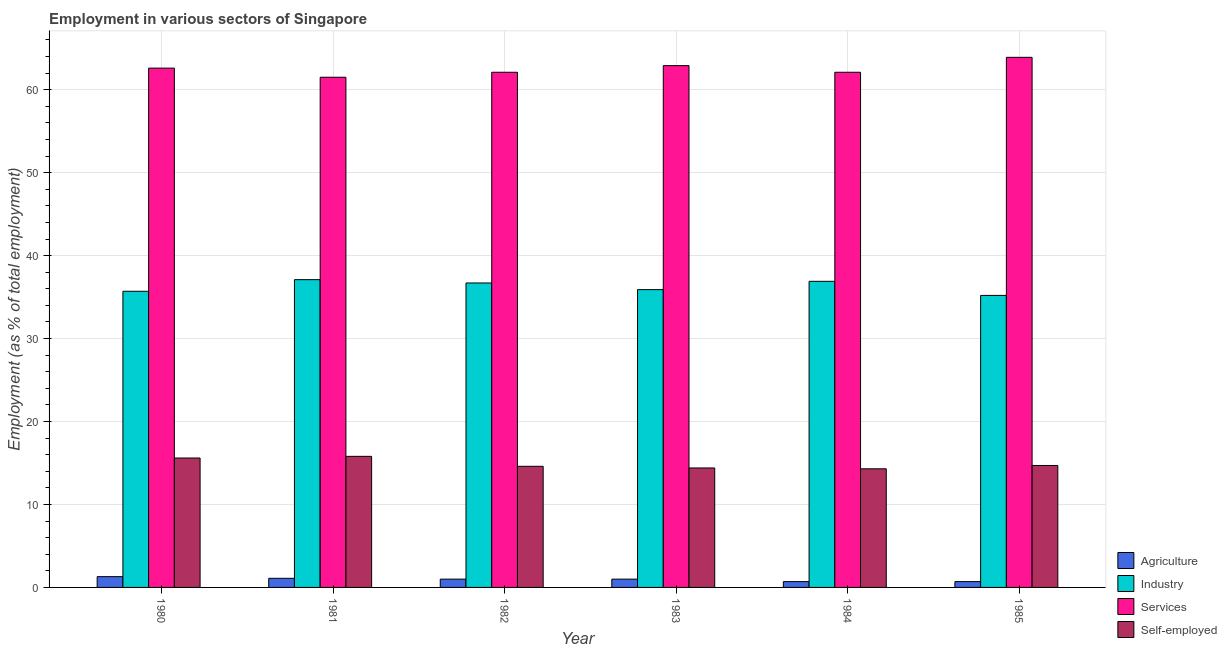How many different coloured bars are there?
Your response must be concise. 4. How many groups of bars are there?
Make the answer very short. 6. Are the number of bars on each tick of the X-axis equal?
Your answer should be very brief. Yes. How many bars are there on the 2nd tick from the left?
Ensure brevity in your answer.  4. In how many cases, is the number of bars for a given year not equal to the number of legend labels?
Make the answer very short. 0. What is the percentage of workers in services in 1981?
Offer a terse response. 61.5. Across all years, what is the maximum percentage of workers in services?
Provide a short and direct response. 63.9. Across all years, what is the minimum percentage of workers in agriculture?
Your response must be concise. 0.7. In which year was the percentage of workers in services minimum?
Give a very brief answer. 1981. What is the total percentage of workers in agriculture in the graph?
Offer a terse response. 5.8. What is the difference between the percentage of workers in industry in 1981 and that in 1985?
Provide a succinct answer. 1.9. What is the difference between the percentage of self employed workers in 1983 and the percentage of workers in industry in 1980?
Provide a short and direct response. -1.2. What is the average percentage of workers in industry per year?
Provide a short and direct response. 36.25. In how many years, is the percentage of workers in agriculture greater than 52 %?
Your answer should be very brief. 0. What is the ratio of the percentage of workers in services in 1981 to that in 1985?
Your response must be concise. 0.96. Is the percentage of workers in services in 1981 less than that in 1982?
Give a very brief answer. Yes. Is the difference between the percentage of self employed workers in 1981 and 1982 greater than the difference between the percentage of workers in industry in 1981 and 1982?
Provide a succinct answer. No. What is the difference between the highest and the second highest percentage of workers in services?
Your response must be concise. 1. What is the difference between the highest and the lowest percentage of self employed workers?
Your answer should be very brief. 1.5. In how many years, is the percentage of self employed workers greater than the average percentage of self employed workers taken over all years?
Your response must be concise. 2. Is it the case that in every year, the sum of the percentage of workers in industry and percentage of workers in agriculture is greater than the sum of percentage of workers in services and percentage of self employed workers?
Offer a very short reply. Yes. What does the 2nd bar from the left in 1984 represents?
Your response must be concise. Industry. What does the 4th bar from the right in 1983 represents?
Offer a very short reply. Agriculture. How many bars are there?
Ensure brevity in your answer.  24. Are all the bars in the graph horizontal?
Keep it short and to the point. No. What is the difference between two consecutive major ticks on the Y-axis?
Your answer should be compact. 10. Does the graph contain grids?
Provide a succinct answer. Yes. How are the legend labels stacked?
Offer a terse response. Vertical. What is the title of the graph?
Provide a short and direct response. Employment in various sectors of Singapore. What is the label or title of the X-axis?
Give a very brief answer. Year. What is the label or title of the Y-axis?
Your answer should be compact. Employment (as % of total employment). What is the Employment (as % of total employment) of Agriculture in 1980?
Offer a very short reply. 1.3. What is the Employment (as % of total employment) of Industry in 1980?
Your response must be concise. 35.7. What is the Employment (as % of total employment) in Services in 1980?
Make the answer very short. 62.6. What is the Employment (as % of total employment) of Self-employed in 1980?
Your answer should be very brief. 15.6. What is the Employment (as % of total employment) in Agriculture in 1981?
Make the answer very short. 1.1. What is the Employment (as % of total employment) in Industry in 1981?
Provide a short and direct response. 37.1. What is the Employment (as % of total employment) in Services in 1981?
Offer a terse response. 61.5. What is the Employment (as % of total employment) in Self-employed in 1981?
Your answer should be compact. 15.8. What is the Employment (as % of total employment) of Industry in 1982?
Provide a succinct answer. 36.7. What is the Employment (as % of total employment) of Services in 1982?
Your answer should be compact. 62.1. What is the Employment (as % of total employment) in Self-employed in 1982?
Your answer should be very brief. 14.6. What is the Employment (as % of total employment) in Industry in 1983?
Ensure brevity in your answer.  35.9. What is the Employment (as % of total employment) in Services in 1983?
Provide a short and direct response. 62.9. What is the Employment (as % of total employment) of Self-employed in 1983?
Offer a very short reply. 14.4. What is the Employment (as % of total employment) in Agriculture in 1984?
Keep it short and to the point. 0.7. What is the Employment (as % of total employment) in Industry in 1984?
Make the answer very short. 36.9. What is the Employment (as % of total employment) in Services in 1984?
Your answer should be very brief. 62.1. What is the Employment (as % of total employment) of Self-employed in 1984?
Make the answer very short. 14.3. What is the Employment (as % of total employment) of Agriculture in 1985?
Offer a very short reply. 0.7. What is the Employment (as % of total employment) of Industry in 1985?
Ensure brevity in your answer.  35.2. What is the Employment (as % of total employment) of Services in 1985?
Your answer should be compact. 63.9. What is the Employment (as % of total employment) of Self-employed in 1985?
Keep it short and to the point. 14.7. Across all years, what is the maximum Employment (as % of total employment) in Agriculture?
Give a very brief answer. 1.3. Across all years, what is the maximum Employment (as % of total employment) in Industry?
Offer a very short reply. 37.1. Across all years, what is the maximum Employment (as % of total employment) in Services?
Provide a succinct answer. 63.9. Across all years, what is the maximum Employment (as % of total employment) of Self-employed?
Offer a very short reply. 15.8. Across all years, what is the minimum Employment (as % of total employment) in Agriculture?
Your response must be concise. 0.7. Across all years, what is the minimum Employment (as % of total employment) in Industry?
Your answer should be compact. 35.2. Across all years, what is the minimum Employment (as % of total employment) of Services?
Give a very brief answer. 61.5. Across all years, what is the minimum Employment (as % of total employment) in Self-employed?
Make the answer very short. 14.3. What is the total Employment (as % of total employment) of Agriculture in the graph?
Give a very brief answer. 5.8. What is the total Employment (as % of total employment) of Industry in the graph?
Ensure brevity in your answer.  217.5. What is the total Employment (as % of total employment) in Services in the graph?
Offer a terse response. 375.1. What is the total Employment (as % of total employment) of Self-employed in the graph?
Provide a short and direct response. 89.4. What is the difference between the Employment (as % of total employment) of Industry in 1980 and that in 1981?
Offer a very short reply. -1.4. What is the difference between the Employment (as % of total employment) in Industry in 1980 and that in 1982?
Offer a very short reply. -1. What is the difference between the Employment (as % of total employment) of Services in 1980 and that in 1982?
Give a very brief answer. 0.5. What is the difference between the Employment (as % of total employment) of Agriculture in 1980 and that in 1983?
Ensure brevity in your answer.  0.3. What is the difference between the Employment (as % of total employment) of Industry in 1980 and that in 1983?
Your answer should be very brief. -0.2. What is the difference between the Employment (as % of total employment) in Self-employed in 1980 and that in 1983?
Give a very brief answer. 1.2. What is the difference between the Employment (as % of total employment) of Industry in 1980 and that in 1984?
Provide a short and direct response. -1.2. What is the difference between the Employment (as % of total employment) in Agriculture in 1980 and that in 1985?
Offer a very short reply. 0.6. What is the difference between the Employment (as % of total employment) of Industry in 1980 and that in 1985?
Your answer should be compact. 0.5. What is the difference between the Employment (as % of total employment) of Industry in 1981 and that in 1983?
Your answer should be compact. 1.2. What is the difference between the Employment (as % of total employment) of Self-employed in 1981 and that in 1983?
Provide a short and direct response. 1.4. What is the difference between the Employment (as % of total employment) in Industry in 1981 and that in 1984?
Ensure brevity in your answer.  0.2. What is the difference between the Employment (as % of total employment) of Services in 1981 and that in 1984?
Ensure brevity in your answer.  -0.6. What is the difference between the Employment (as % of total employment) of Self-employed in 1981 and that in 1984?
Provide a short and direct response. 1.5. What is the difference between the Employment (as % of total employment) in Industry in 1982 and that in 1983?
Offer a terse response. 0.8. What is the difference between the Employment (as % of total employment) of Services in 1982 and that in 1983?
Make the answer very short. -0.8. What is the difference between the Employment (as % of total employment) in Self-employed in 1982 and that in 1983?
Give a very brief answer. 0.2. What is the difference between the Employment (as % of total employment) in Agriculture in 1982 and that in 1984?
Ensure brevity in your answer.  0.3. What is the difference between the Employment (as % of total employment) of Industry in 1982 and that in 1984?
Make the answer very short. -0.2. What is the difference between the Employment (as % of total employment) in Agriculture in 1982 and that in 1985?
Make the answer very short. 0.3. What is the difference between the Employment (as % of total employment) of Self-employed in 1982 and that in 1985?
Offer a very short reply. -0.1. What is the difference between the Employment (as % of total employment) in Services in 1983 and that in 1984?
Offer a very short reply. 0.8. What is the difference between the Employment (as % of total employment) of Self-employed in 1983 and that in 1984?
Keep it short and to the point. 0.1. What is the difference between the Employment (as % of total employment) in Industry in 1983 and that in 1985?
Keep it short and to the point. 0.7. What is the difference between the Employment (as % of total employment) in Services in 1983 and that in 1985?
Ensure brevity in your answer.  -1. What is the difference between the Employment (as % of total employment) in Services in 1984 and that in 1985?
Provide a succinct answer. -1.8. What is the difference between the Employment (as % of total employment) in Agriculture in 1980 and the Employment (as % of total employment) in Industry in 1981?
Make the answer very short. -35.8. What is the difference between the Employment (as % of total employment) of Agriculture in 1980 and the Employment (as % of total employment) of Services in 1981?
Offer a very short reply. -60.2. What is the difference between the Employment (as % of total employment) of Agriculture in 1980 and the Employment (as % of total employment) of Self-employed in 1981?
Offer a very short reply. -14.5. What is the difference between the Employment (as % of total employment) in Industry in 1980 and the Employment (as % of total employment) in Services in 1981?
Make the answer very short. -25.8. What is the difference between the Employment (as % of total employment) of Industry in 1980 and the Employment (as % of total employment) of Self-employed in 1981?
Make the answer very short. 19.9. What is the difference between the Employment (as % of total employment) in Services in 1980 and the Employment (as % of total employment) in Self-employed in 1981?
Offer a very short reply. 46.8. What is the difference between the Employment (as % of total employment) in Agriculture in 1980 and the Employment (as % of total employment) in Industry in 1982?
Ensure brevity in your answer.  -35.4. What is the difference between the Employment (as % of total employment) of Agriculture in 1980 and the Employment (as % of total employment) of Services in 1982?
Your answer should be very brief. -60.8. What is the difference between the Employment (as % of total employment) of Industry in 1980 and the Employment (as % of total employment) of Services in 1982?
Your answer should be compact. -26.4. What is the difference between the Employment (as % of total employment) of Industry in 1980 and the Employment (as % of total employment) of Self-employed in 1982?
Provide a short and direct response. 21.1. What is the difference between the Employment (as % of total employment) of Agriculture in 1980 and the Employment (as % of total employment) of Industry in 1983?
Give a very brief answer. -34.6. What is the difference between the Employment (as % of total employment) in Agriculture in 1980 and the Employment (as % of total employment) in Services in 1983?
Your answer should be very brief. -61.6. What is the difference between the Employment (as % of total employment) of Industry in 1980 and the Employment (as % of total employment) of Services in 1983?
Offer a very short reply. -27.2. What is the difference between the Employment (as % of total employment) of Industry in 1980 and the Employment (as % of total employment) of Self-employed in 1983?
Your response must be concise. 21.3. What is the difference between the Employment (as % of total employment) of Services in 1980 and the Employment (as % of total employment) of Self-employed in 1983?
Your answer should be very brief. 48.2. What is the difference between the Employment (as % of total employment) of Agriculture in 1980 and the Employment (as % of total employment) of Industry in 1984?
Ensure brevity in your answer.  -35.6. What is the difference between the Employment (as % of total employment) of Agriculture in 1980 and the Employment (as % of total employment) of Services in 1984?
Provide a short and direct response. -60.8. What is the difference between the Employment (as % of total employment) of Agriculture in 1980 and the Employment (as % of total employment) of Self-employed in 1984?
Provide a short and direct response. -13. What is the difference between the Employment (as % of total employment) of Industry in 1980 and the Employment (as % of total employment) of Services in 1984?
Provide a succinct answer. -26.4. What is the difference between the Employment (as % of total employment) of Industry in 1980 and the Employment (as % of total employment) of Self-employed in 1984?
Give a very brief answer. 21.4. What is the difference between the Employment (as % of total employment) of Services in 1980 and the Employment (as % of total employment) of Self-employed in 1984?
Your response must be concise. 48.3. What is the difference between the Employment (as % of total employment) in Agriculture in 1980 and the Employment (as % of total employment) in Industry in 1985?
Your answer should be very brief. -33.9. What is the difference between the Employment (as % of total employment) in Agriculture in 1980 and the Employment (as % of total employment) in Services in 1985?
Your answer should be compact. -62.6. What is the difference between the Employment (as % of total employment) in Industry in 1980 and the Employment (as % of total employment) in Services in 1985?
Provide a short and direct response. -28.2. What is the difference between the Employment (as % of total employment) in Industry in 1980 and the Employment (as % of total employment) in Self-employed in 1985?
Make the answer very short. 21. What is the difference between the Employment (as % of total employment) of Services in 1980 and the Employment (as % of total employment) of Self-employed in 1985?
Offer a terse response. 47.9. What is the difference between the Employment (as % of total employment) in Agriculture in 1981 and the Employment (as % of total employment) in Industry in 1982?
Offer a very short reply. -35.6. What is the difference between the Employment (as % of total employment) of Agriculture in 1981 and the Employment (as % of total employment) of Services in 1982?
Keep it short and to the point. -61. What is the difference between the Employment (as % of total employment) in Services in 1981 and the Employment (as % of total employment) in Self-employed in 1982?
Keep it short and to the point. 46.9. What is the difference between the Employment (as % of total employment) in Agriculture in 1981 and the Employment (as % of total employment) in Industry in 1983?
Give a very brief answer. -34.8. What is the difference between the Employment (as % of total employment) in Agriculture in 1981 and the Employment (as % of total employment) in Services in 1983?
Make the answer very short. -61.8. What is the difference between the Employment (as % of total employment) in Industry in 1981 and the Employment (as % of total employment) in Services in 1983?
Your answer should be compact. -25.8. What is the difference between the Employment (as % of total employment) in Industry in 1981 and the Employment (as % of total employment) in Self-employed in 1983?
Keep it short and to the point. 22.7. What is the difference between the Employment (as % of total employment) in Services in 1981 and the Employment (as % of total employment) in Self-employed in 1983?
Ensure brevity in your answer.  47.1. What is the difference between the Employment (as % of total employment) in Agriculture in 1981 and the Employment (as % of total employment) in Industry in 1984?
Make the answer very short. -35.8. What is the difference between the Employment (as % of total employment) in Agriculture in 1981 and the Employment (as % of total employment) in Services in 1984?
Offer a very short reply. -61. What is the difference between the Employment (as % of total employment) of Industry in 1981 and the Employment (as % of total employment) of Self-employed in 1984?
Your response must be concise. 22.8. What is the difference between the Employment (as % of total employment) of Services in 1981 and the Employment (as % of total employment) of Self-employed in 1984?
Make the answer very short. 47.2. What is the difference between the Employment (as % of total employment) in Agriculture in 1981 and the Employment (as % of total employment) in Industry in 1985?
Keep it short and to the point. -34.1. What is the difference between the Employment (as % of total employment) in Agriculture in 1981 and the Employment (as % of total employment) in Services in 1985?
Your answer should be compact. -62.8. What is the difference between the Employment (as % of total employment) of Industry in 1981 and the Employment (as % of total employment) of Services in 1985?
Make the answer very short. -26.8. What is the difference between the Employment (as % of total employment) of Industry in 1981 and the Employment (as % of total employment) of Self-employed in 1985?
Your answer should be very brief. 22.4. What is the difference between the Employment (as % of total employment) of Services in 1981 and the Employment (as % of total employment) of Self-employed in 1985?
Ensure brevity in your answer.  46.8. What is the difference between the Employment (as % of total employment) of Agriculture in 1982 and the Employment (as % of total employment) of Industry in 1983?
Make the answer very short. -34.9. What is the difference between the Employment (as % of total employment) in Agriculture in 1982 and the Employment (as % of total employment) in Services in 1983?
Your answer should be compact. -61.9. What is the difference between the Employment (as % of total employment) of Industry in 1982 and the Employment (as % of total employment) of Services in 1983?
Offer a terse response. -26.2. What is the difference between the Employment (as % of total employment) of Industry in 1982 and the Employment (as % of total employment) of Self-employed in 1983?
Ensure brevity in your answer.  22.3. What is the difference between the Employment (as % of total employment) in Services in 1982 and the Employment (as % of total employment) in Self-employed in 1983?
Make the answer very short. 47.7. What is the difference between the Employment (as % of total employment) of Agriculture in 1982 and the Employment (as % of total employment) of Industry in 1984?
Your answer should be compact. -35.9. What is the difference between the Employment (as % of total employment) in Agriculture in 1982 and the Employment (as % of total employment) in Services in 1984?
Provide a short and direct response. -61.1. What is the difference between the Employment (as % of total employment) in Industry in 1982 and the Employment (as % of total employment) in Services in 1984?
Your answer should be compact. -25.4. What is the difference between the Employment (as % of total employment) in Industry in 1982 and the Employment (as % of total employment) in Self-employed in 1984?
Keep it short and to the point. 22.4. What is the difference between the Employment (as % of total employment) of Services in 1982 and the Employment (as % of total employment) of Self-employed in 1984?
Ensure brevity in your answer.  47.8. What is the difference between the Employment (as % of total employment) in Agriculture in 1982 and the Employment (as % of total employment) in Industry in 1985?
Make the answer very short. -34.2. What is the difference between the Employment (as % of total employment) of Agriculture in 1982 and the Employment (as % of total employment) of Services in 1985?
Offer a very short reply. -62.9. What is the difference between the Employment (as % of total employment) of Agriculture in 1982 and the Employment (as % of total employment) of Self-employed in 1985?
Give a very brief answer. -13.7. What is the difference between the Employment (as % of total employment) of Industry in 1982 and the Employment (as % of total employment) of Services in 1985?
Ensure brevity in your answer.  -27.2. What is the difference between the Employment (as % of total employment) in Services in 1982 and the Employment (as % of total employment) in Self-employed in 1985?
Provide a succinct answer. 47.4. What is the difference between the Employment (as % of total employment) of Agriculture in 1983 and the Employment (as % of total employment) of Industry in 1984?
Offer a terse response. -35.9. What is the difference between the Employment (as % of total employment) of Agriculture in 1983 and the Employment (as % of total employment) of Services in 1984?
Ensure brevity in your answer.  -61.1. What is the difference between the Employment (as % of total employment) in Agriculture in 1983 and the Employment (as % of total employment) in Self-employed in 1984?
Ensure brevity in your answer.  -13.3. What is the difference between the Employment (as % of total employment) in Industry in 1983 and the Employment (as % of total employment) in Services in 1984?
Make the answer very short. -26.2. What is the difference between the Employment (as % of total employment) of Industry in 1983 and the Employment (as % of total employment) of Self-employed in 1984?
Your answer should be compact. 21.6. What is the difference between the Employment (as % of total employment) of Services in 1983 and the Employment (as % of total employment) of Self-employed in 1984?
Provide a short and direct response. 48.6. What is the difference between the Employment (as % of total employment) in Agriculture in 1983 and the Employment (as % of total employment) in Industry in 1985?
Keep it short and to the point. -34.2. What is the difference between the Employment (as % of total employment) in Agriculture in 1983 and the Employment (as % of total employment) in Services in 1985?
Your response must be concise. -62.9. What is the difference between the Employment (as % of total employment) in Agriculture in 1983 and the Employment (as % of total employment) in Self-employed in 1985?
Give a very brief answer. -13.7. What is the difference between the Employment (as % of total employment) in Industry in 1983 and the Employment (as % of total employment) in Services in 1985?
Your answer should be very brief. -28. What is the difference between the Employment (as % of total employment) in Industry in 1983 and the Employment (as % of total employment) in Self-employed in 1985?
Keep it short and to the point. 21.2. What is the difference between the Employment (as % of total employment) of Services in 1983 and the Employment (as % of total employment) of Self-employed in 1985?
Your answer should be very brief. 48.2. What is the difference between the Employment (as % of total employment) of Agriculture in 1984 and the Employment (as % of total employment) of Industry in 1985?
Give a very brief answer. -34.5. What is the difference between the Employment (as % of total employment) in Agriculture in 1984 and the Employment (as % of total employment) in Services in 1985?
Offer a terse response. -63.2. What is the difference between the Employment (as % of total employment) of Industry in 1984 and the Employment (as % of total employment) of Services in 1985?
Your response must be concise. -27. What is the difference between the Employment (as % of total employment) of Services in 1984 and the Employment (as % of total employment) of Self-employed in 1985?
Your answer should be very brief. 47.4. What is the average Employment (as % of total employment) of Agriculture per year?
Give a very brief answer. 0.97. What is the average Employment (as % of total employment) of Industry per year?
Your answer should be compact. 36.25. What is the average Employment (as % of total employment) of Services per year?
Your answer should be compact. 62.52. What is the average Employment (as % of total employment) in Self-employed per year?
Offer a terse response. 14.9. In the year 1980, what is the difference between the Employment (as % of total employment) of Agriculture and Employment (as % of total employment) of Industry?
Provide a short and direct response. -34.4. In the year 1980, what is the difference between the Employment (as % of total employment) in Agriculture and Employment (as % of total employment) in Services?
Your answer should be compact. -61.3. In the year 1980, what is the difference between the Employment (as % of total employment) in Agriculture and Employment (as % of total employment) in Self-employed?
Your answer should be compact. -14.3. In the year 1980, what is the difference between the Employment (as % of total employment) of Industry and Employment (as % of total employment) of Services?
Ensure brevity in your answer.  -26.9. In the year 1980, what is the difference between the Employment (as % of total employment) in Industry and Employment (as % of total employment) in Self-employed?
Keep it short and to the point. 20.1. In the year 1980, what is the difference between the Employment (as % of total employment) in Services and Employment (as % of total employment) in Self-employed?
Offer a terse response. 47. In the year 1981, what is the difference between the Employment (as % of total employment) in Agriculture and Employment (as % of total employment) in Industry?
Provide a succinct answer. -36. In the year 1981, what is the difference between the Employment (as % of total employment) of Agriculture and Employment (as % of total employment) of Services?
Your answer should be compact. -60.4. In the year 1981, what is the difference between the Employment (as % of total employment) of Agriculture and Employment (as % of total employment) of Self-employed?
Your answer should be very brief. -14.7. In the year 1981, what is the difference between the Employment (as % of total employment) in Industry and Employment (as % of total employment) in Services?
Ensure brevity in your answer.  -24.4. In the year 1981, what is the difference between the Employment (as % of total employment) of Industry and Employment (as % of total employment) of Self-employed?
Keep it short and to the point. 21.3. In the year 1981, what is the difference between the Employment (as % of total employment) of Services and Employment (as % of total employment) of Self-employed?
Offer a terse response. 45.7. In the year 1982, what is the difference between the Employment (as % of total employment) in Agriculture and Employment (as % of total employment) in Industry?
Offer a very short reply. -35.7. In the year 1982, what is the difference between the Employment (as % of total employment) of Agriculture and Employment (as % of total employment) of Services?
Keep it short and to the point. -61.1. In the year 1982, what is the difference between the Employment (as % of total employment) in Industry and Employment (as % of total employment) in Services?
Provide a succinct answer. -25.4. In the year 1982, what is the difference between the Employment (as % of total employment) in Industry and Employment (as % of total employment) in Self-employed?
Your response must be concise. 22.1. In the year 1982, what is the difference between the Employment (as % of total employment) of Services and Employment (as % of total employment) of Self-employed?
Your response must be concise. 47.5. In the year 1983, what is the difference between the Employment (as % of total employment) of Agriculture and Employment (as % of total employment) of Industry?
Provide a short and direct response. -34.9. In the year 1983, what is the difference between the Employment (as % of total employment) of Agriculture and Employment (as % of total employment) of Services?
Your answer should be very brief. -61.9. In the year 1983, what is the difference between the Employment (as % of total employment) of Industry and Employment (as % of total employment) of Services?
Your answer should be compact. -27. In the year 1983, what is the difference between the Employment (as % of total employment) in Industry and Employment (as % of total employment) in Self-employed?
Offer a very short reply. 21.5. In the year 1983, what is the difference between the Employment (as % of total employment) of Services and Employment (as % of total employment) of Self-employed?
Offer a terse response. 48.5. In the year 1984, what is the difference between the Employment (as % of total employment) of Agriculture and Employment (as % of total employment) of Industry?
Ensure brevity in your answer.  -36.2. In the year 1984, what is the difference between the Employment (as % of total employment) of Agriculture and Employment (as % of total employment) of Services?
Your response must be concise. -61.4. In the year 1984, what is the difference between the Employment (as % of total employment) of Industry and Employment (as % of total employment) of Services?
Your response must be concise. -25.2. In the year 1984, what is the difference between the Employment (as % of total employment) in Industry and Employment (as % of total employment) in Self-employed?
Keep it short and to the point. 22.6. In the year 1984, what is the difference between the Employment (as % of total employment) of Services and Employment (as % of total employment) of Self-employed?
Make the answer very short. 47.8. In the year 1985, what is the difference between the Employment (as % of total employment) of Agriculture and Employment (as % of total employment) of Industry?
Keep it short and to the point. -34.5. In the year 1985, what is the difference between the Employment (as % of total employment) of Agriculture and Employment (as % of total employment) of Services?
Provide a succinct answer. -63.2. In the year 1985, what is the difference between the Employment (as % of total employment) in Agriculture and Employment (as % of total employment) in Self-employed?
Your answer should be compact. -14. In the year 1985, what is the difference between the Employment (as % of total employment) in Industry and Employment (as % of total employment) in Services?
Your response must be concise. -28.7. In the year 1985, what is the difference between the Employment (as % of total employment) of Industry and Employment (as % of total employment) of Self-employed?
Keep it short and to the point. 20.5. In the year 1985, what is the difference between the Employment (as % of total employment) of Services and Employment (as % of total employment) of Self-employed?
Make the answer very short. 49.2. What is the ratio of the Employment (as % of total employment) of Agriculture in 1980 to that in 1981?
Provide a short and direct response. 1.18. What is the ratio of the Employment (as % of total employment) of Industry in 1980 to that in 1981?
Offer a terse response. 0.96. What is the ratio of the Employment (as % of total employment) of Services in 1980 to that in 1981?
Offer a terse response. 1.02. What is the ratio of the Employment (as % of total employment) in Self-employed in 1980 to that in 1981?
Ensure brevity in your answer.  0.99. What is the ratio of the Employment (as % of total employment) in Agriculture in 1980 to that in 1982?
Give a very brief answer. 1.3. What is the ratio of the Employment (as % of total employment) in Industry in 1980 to that in 1982?
Your answer should be compact. 0.97. What is the ratio of the Employment (as % of total employment) in Services in 1980 to that in 1982?
Provide a succinct answer. 1.01. What is the ratio of the Employment (as % of total employment) in Self-employed in 1980 to that in 1982?
Ensure brevity in your answer.  1.07. What is the ratio of the Employment (as % of total employment) of Agriculture in 1980 to that in 1983?
Give a very brief answer. 1.3. What is the ratio of the Employment (as % of total employment) in Self-employed in 1980 to that in 1983?
Provide a short and direct response. 1.08. What is the ratio of the Employment (as % of total employment) of Agriculture in 1980 to that in 1984?
Your answer should be very brief. 1.86. What is the ratio of the Employment (as % of total employment) in Industry in 1980 to that in 1984?
Make the answer very short. 0.97. What is the ratio of the Employment (as % of total employment) of Agriculture in 1980 to that in 1985?
Offer a terse response. 1.86. What is the ratio of the Employment (as % of total employment) of Industry in 1980 to that in 1985?
Keep it short and to the point. 1.01. What is the ratio of the Employment (as % of total employment) in Services in 1980 to that in 1985?
Your answer should be very brief. 0.98. What is the ratio of the Employment (as % of total employment) in Self-employed in 1980 to that in 1985?
Your answer should be very brief. 1.06. What is the ratio of the Employment (as % of total employment) in Industry in 1981 to that in 1982?
Your answer should be very brief. 1.01. What is the ratio of the Employment (as % of total employment) in Services in 1981 to that in 1982?
Your response must be concise. 0.99. What is the ratio of the Employment (as % of total employment) in Self-employed in 1981 to that in 1982?
Offer a very short reply. 1.08. What is the ratio of the Employment (as % of total employment) of Industry in 1981 to that in 1983?
Ensure brevity in your answer.  1.03. What is the ratio of the Employment (as % of total employment) of Services in 1981 to that in 1983?
Offer a terse response. 0.98. What is the ratio of the Employment (as % of total employment) of Self-employed in 1981 to that in 1983?
Provide a short and direct response. 1.1. What is the ratio of the Employment (as % of total employment) of Agriculture in 1981 to that in 1984?
Your response must be concise. 1.57. What is the ratio of the Employment (as % of total employment) in Industry in 1981 to that in 1984?
Offer a very short reply. 1.01. What is the ratio of the Employment (as % of total employment) in Services in 1981 to that in 1984?
Offer a very short reply. 0.99. What is the ratio of the Employment (as % of total employment) of Self-employed in 1981 to that in 1984?
Your response must be concise. 1.1. What is the ratio of the Employment (as % of total employment) in Agriculture in 1981 to that in 1985?
Ensure brevity in your answer.  1.57. What is the ratio of the Employment (as % of total employment) in Industry in 1981 to that in 1985?
Provide a short and direct response. 1.05. What is the ratio of the Employment (as % of total employment) in Services in 1981 to that in 1985?
Your answer should be very brief. 0.96. What is the ratio of the Employment (as % of total employment) in Self-employed in 1981 to that in 1985?
Offer a terse response. 1.07. What is the ratio of the Employment (as % of total employment) in Agriculture in 1982 to that in 1983?
Keep it short and to the point. 1. What is the ratio of the Employment (as % of total employment) in Industry in 1982 to that in 1983?
Provide a succinct answer. 1.02. What is the ratio of the Employment (as % of total employment) in Services in 1982 to that in 1983?
Ensure brevity in your answer.  0.99. What is the ratio of the Employment (as % of total employment) of Self-employed in 1982 to that in 1983?
Give a very brief answer. 1.01. What is the ratio of the Employment (as % of total employment) in Agriculture in 1982 to that in 1984?
Provide a succinct answer. 1.43. What is the ratio of the Employment (as % of total employment) in Self-employed in 1982 to that in 1984?
Your answer should be very brief. 1.02. What is the ratio of the Employment (as % of total employment) of Agriculture in 1982 to that in 1985?
Provide a short and direct response. 1.43. What is the ratio of the Employment (as % of total employment) of Industry in 1982 to that in 1985?
Provide a succinct answer. 1.04. What is the ratio of the Employment (as % of total employment) of Services in 1982 to that in 1985?
Give a very brief answer. 0.97. What is the ratio of the Employment (as % of total employment) in Self-employed in 1982 to that in 1985?
Your answer should be very brief. 0.99. What is the ratio of the Employment (as % of total employment) in Agriculture in 1983 to that in 1984?
Your answer should be very brief. 1.43. What is the ratio of the Employment (as % of total employment) of Industry in 1983 to that in 1984?
Provide a succinct answer. 0.97. What is the ratio of the Employment (as % of total employment) of Services in 1983 to that in 1984?
Ensure brevity in your answer.  1.01. What is the ratio of the Employment (as % of total employment) of Self-employed in 1983 to that in 1984?
Offer a terse response. 1.01. What is the ratio of the Employment (as % of total employment) in Agriculture in 1983 to that in 1985?
Provide a short and direct response. 1.43. What is the ratio of the Employment (as % of total employment) of Industry in 1983 to that in 1985?
Your answer should be compact. 1.02. What is the ratio of the Employment (as % of total employment) in Services in 1983 to that in 1985?
Offer a terse response. 0.98. What is the ratio of the Employment (as % of total employment) of Self-employed in 1983 to that in 1985?
Ensure brevity in your answer.  0.98. What is the ratio of the Employment (as % of total employment) in Industry in 1984 to that in 1985?
Your response must be concise. 1.05. What is the ratio of the Employment (as % of total employment) in Services in 1984 to that in 1985?
Provide a succinct answer. 0.97. What is the ratio of the Employment (as % of total employment) of Self-employed in 1984 to that in 1985?
Offer a very short reply. 0.97. What is the difference between the highest and the second highest Employment (as % of total employment) in Self-employed?
Keep it short and to the point. 0.2. What is the difference between the highest and the lowest Employment (as % of total employment) of Industry?
Make the answer very short. 1.9. What is the difference between the highest and the lowest Employment (as % of total employment) in Services?
Give a very brief answer. 2.4. What is the difference between the highest and the lowest Employment (as % of total employment) in Self-employed?
Offer a terse response. 1.5. 